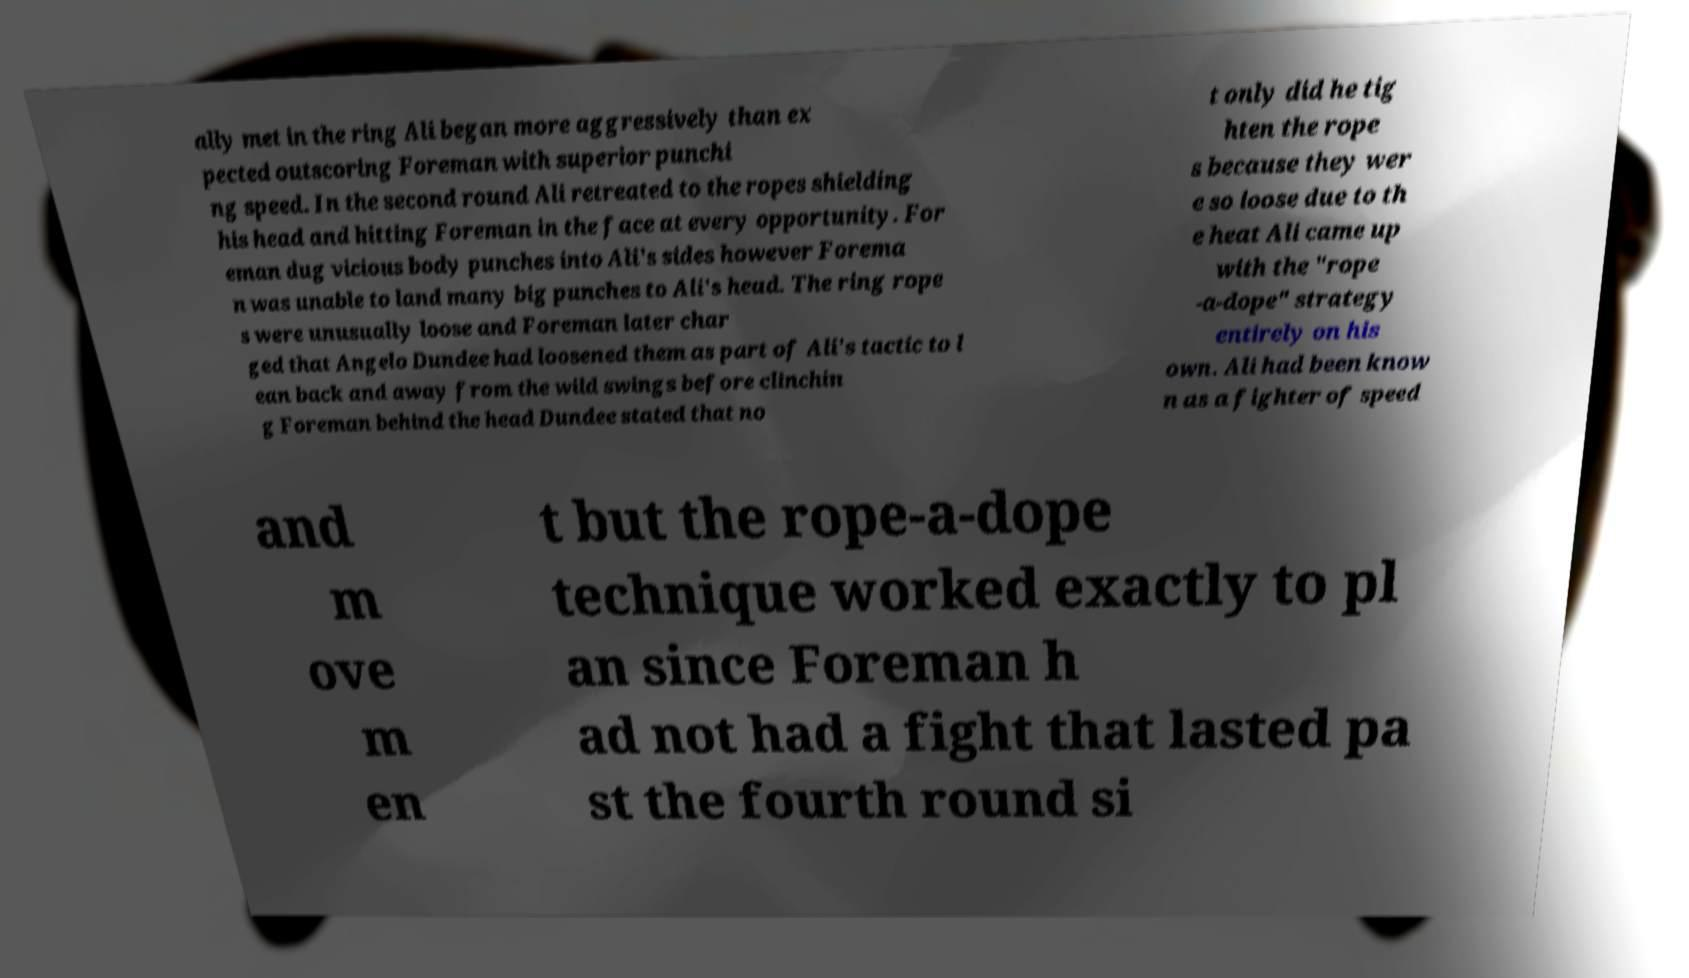There's text embedded in this image that I need extracted. Can you transcribe it verbatim? ally met in the ring Ali began more aggressively than ex pected outscoring Foreman with superior punchi ng speed. In the second round Ali retreated to the ropes shielding his head and hitting Foreman in the face at every opportunity. For eman dug vicious body punches into Ali's sides however Forema n was unable to land many big punches to Ali's head. The ring rope s were unusually loose and Foreman later char ged that Angelo Dundee had loosened them as part of Ali's tactic to l ean back and away from the wild swings before clinchin g Foreman behind the head Dundee stated that no t only did he tig hten the rope s because they wer e so loose due to th e heat Ali came up with the "rope -a-dope" strategy entirely on his own. Ali had been know n as a fighter of speed and m ove m en t but the rope-a-dope technique worked exactly to pl an since Foreman h ad not had a fight that lasted pa st the fourth round si 